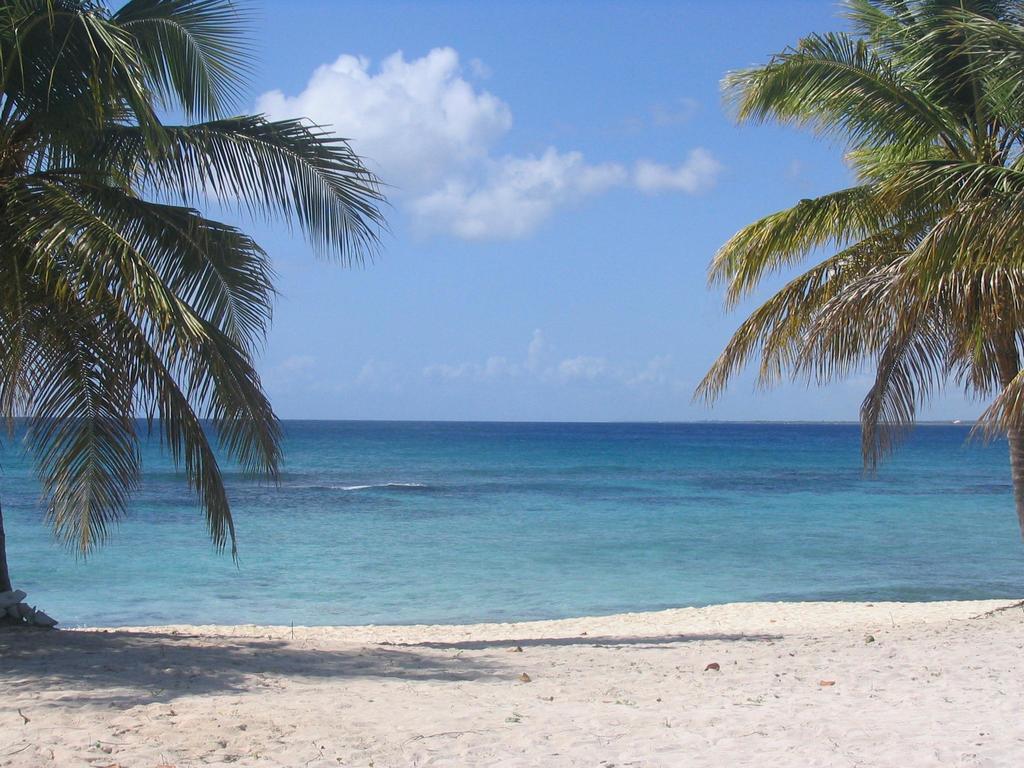Could you give a brief overview of what you see in this image? In this image we can see the trees and water, in the background, we can see the sky with clouds. 